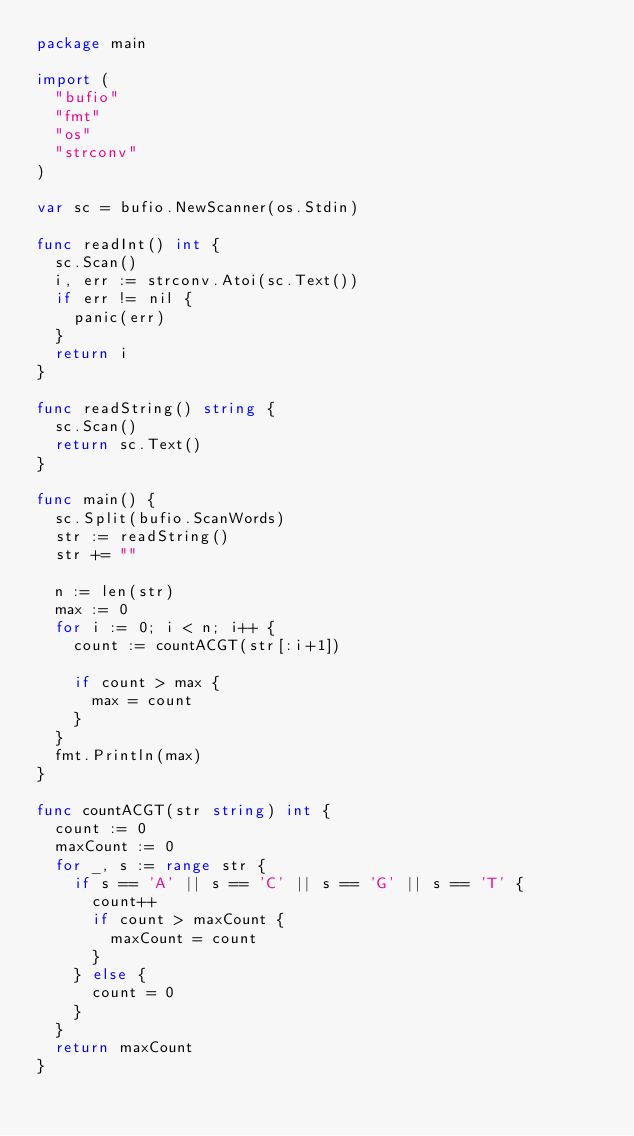Convert code to text. <code><loc_0><loc_0><loc_500><loc_500><_Go_>package main

import (
	"bufio"
	"fmt"
	"os"
	"strconv"
)

var sc = bufio.NewScanner(os.Stdin)

func readInt() int {
	sc.Scan()
	i, err := strconv.Atoi(sc.Text())
	if err != nil {
		panic(err)
	}
	return i
}

func readString() string {
	sc.Scan()
	return sc.Text()
}

func main() {
	sc.Split(bufio.ScanWords)
	str := readString()
	str += ""

	n := len(str)
	max := 0
	for i := 0; i < n; i++ {
		count := countACGT(str[:i+1])

		if count > max {
			max = count
		}
	}
	fmt.Println(max)
}

func countACGT(str string) int {
	count := 0
	maxCount := 0
	for _, s := range str {
		if s == 'A' || s == 'C' || s == 'G' || s == 'T' {
			count++
			if count > maxCount {
				maxCount = count
			}
		} else {
			count = 0
		}
	}
	return maxCount
}
</code> 